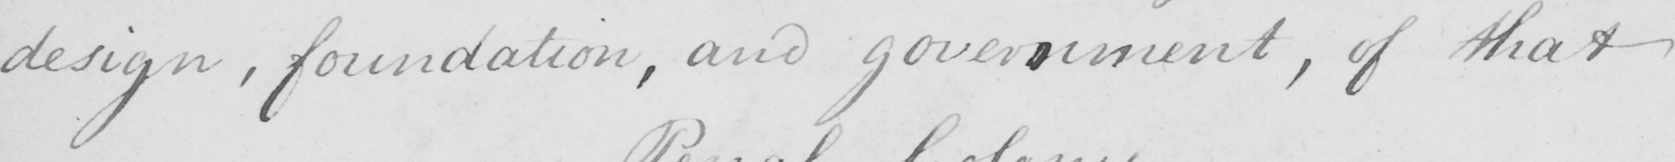Please provide the text content of this handwritten line. design , foundation , and government , of that 